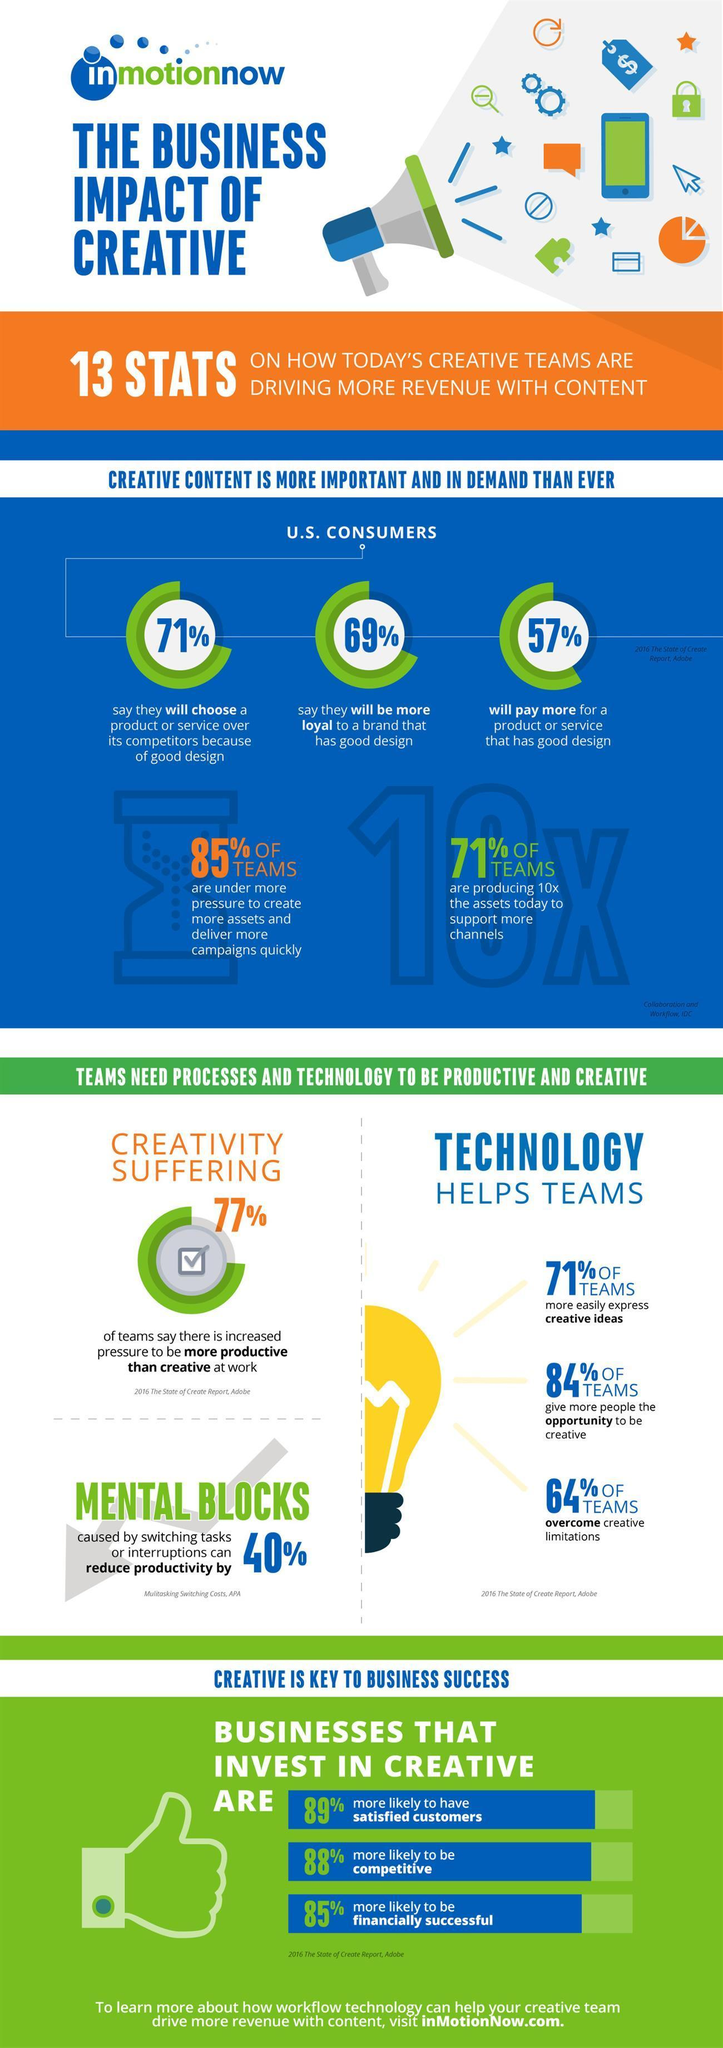how much does technology help team for more opportunity to be creative
Answer the question with a short phrase. 84% how many suffer from mental blocks 40% how many have brand loyalty with good design 69% what is the colour of the light bulb, yellow or white? yellow how many will choose products for good design 71% what does 77% depict creative suffering 